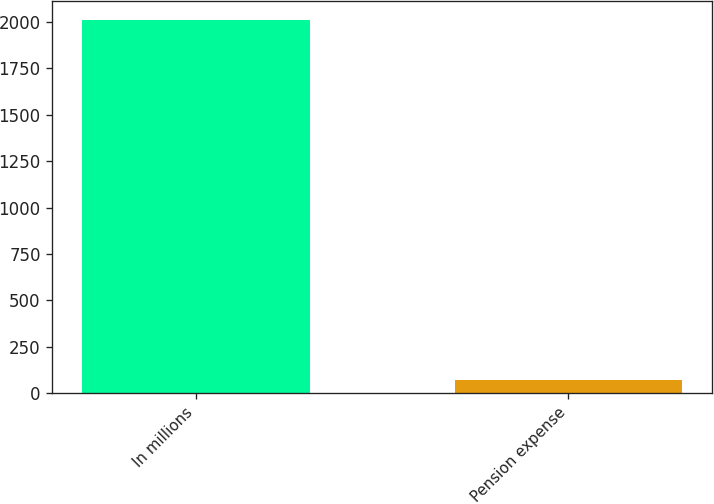Convert chart to OTSL. <chart><loc_0><loc_0><loc_500><loc_500><bar_chart><fcel>In millions<fcel>Pension expense<nl><fcel>2010<fcel>70<nl></chart> 